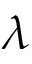Convert formula to latex. <formula><loc_0><loc_0><loc_500><loc_500>\lambda</formula> 